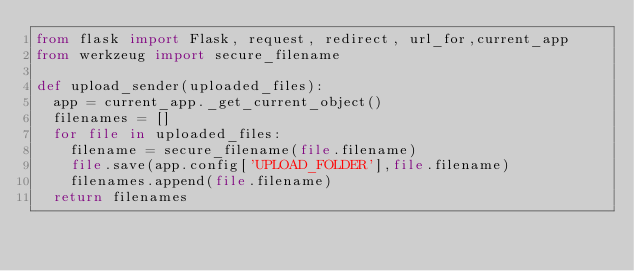Convert code to text. <code><loc_0><loc_0><loc_500><loc_500><_Python_>from flask import Flask, request, redirect, url_for,current_app
from werkzeug import secure_filename

def upload_sender(uploaded_files):
	app = current_app._get_current_object()
	filenames = []
	for file in uploaded_files:
		filename = secure_filename(file.filename)
		file.save(app.config['UPLOAD_FOLDER'],file.filename)
		filenames.append(file.filename)
	return filenames</code> 